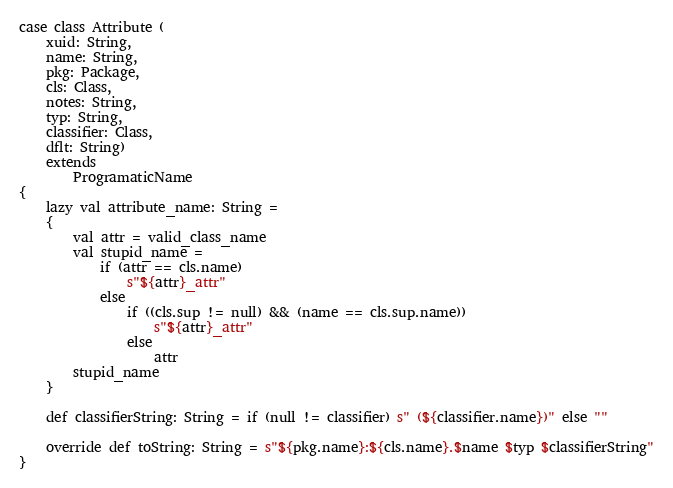Convert code to text. <code><loc_0><loc_0><loc_500><loc_500><_Scala_>case class Attribute (
    xuid: String,
    name: String,
    pkg: Package,
    cls: Class,
    notes: String,
    typ: String,
    classifier: Class,
    dflt: String)
    extends
        ProgramaticName
{
    lazy val attribute_name: String =
    {
        val attr = valid_class_name
        val stupid_name =
            if (attr == cls.name)
                s"${attr}_attr"
            else
                if ((cls.sup != null) && (name == cls.sup.name))
                    s"${attr}_attr"
                else
                    attr
        stupid_name
    }

    def classifierString: String = if (null != classifier) s" (${classifier.name})" else ""

    override def toString: String = s"${pkg.name}:${cls.name}.$name $typ $classifierString"
}
</code> 